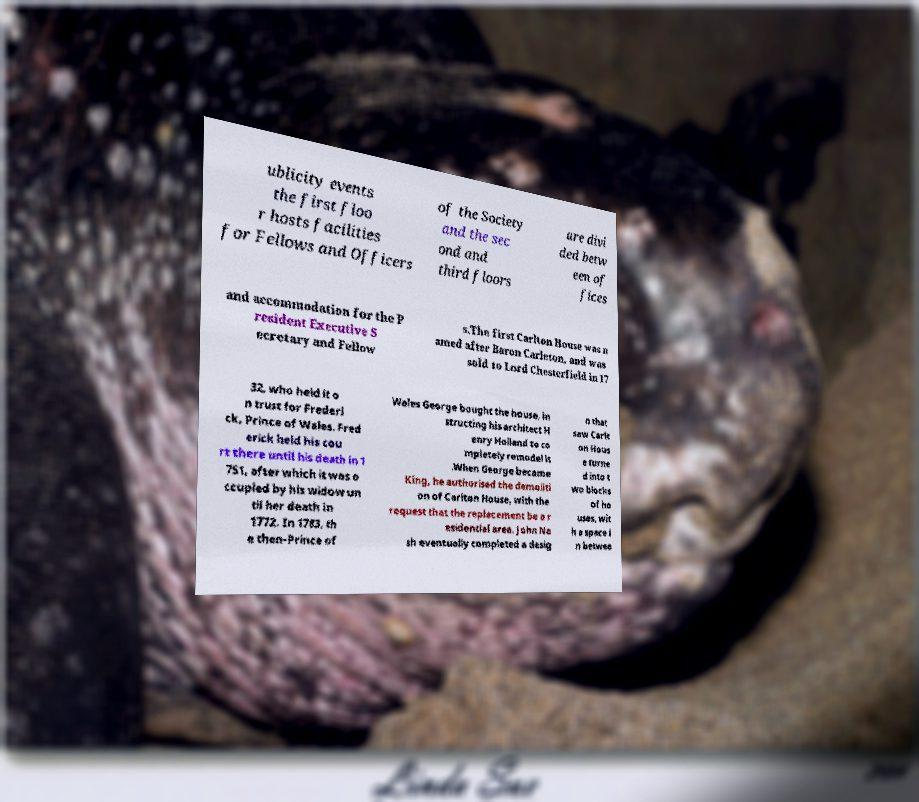What messages or text are displayed in this image? I need them in a readable, typed format. ublicity events the first floo r hosts facilities for Fellows and Officers of the Society and the sec ond and third floors are divi ded betw een of fices and accommodation for the P resident Executive S ecretary and Fellow s.The first Carlton House was n amed after Baron Carleton, and was sold to Lord Chesterfield in 17 32, who held it o n trust for Frederi ck, Prince of Wales. Fred erick held his cou rt there until his death in 1 751, after which it was o ccupied by his widow un til her death in 1772. In 1783, th e then-Prince of Wales George bought the house, in structing his architect H enry Holland to co mpletely remodel it .When George became King, he authorised the demoliti on of Carlton House, with the request that the replacement be a r esidential area. John Na sh eventually completed a desig n that saw Carlt on Hous e turne d into t wo blocks of ho uses, wit h a space i n betwee 